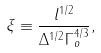Convert formula to latex. <formula><loc_0><loc_0><loc_500><loc_500>\xi \equiv \frac { l ^ { 1 / 2 } } { \Delta ^ { 1 / 2 } \Gamma _ { o } ^ { 4 / 3 } } ,</formula> 